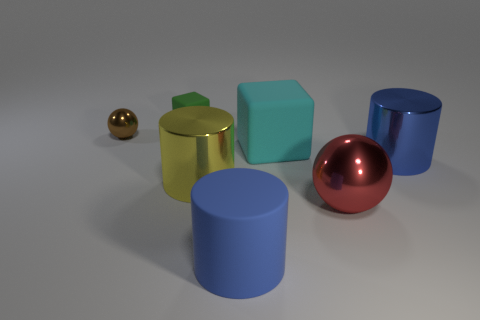Add 1 tiny red matte blocks. How many objects exist? 8 Subtract all blocks. How many objects are left? 5 Add 7 big purple metal spheres. How many big purple metal spheres exist? 7 Subtract 0 cyan cylinders. How many objects are left? 7 Subtract all tiny green spheres. Subtract all brown things. How many objects are left? 6 Add 1 green cubes. How many green cubes are left? 2 